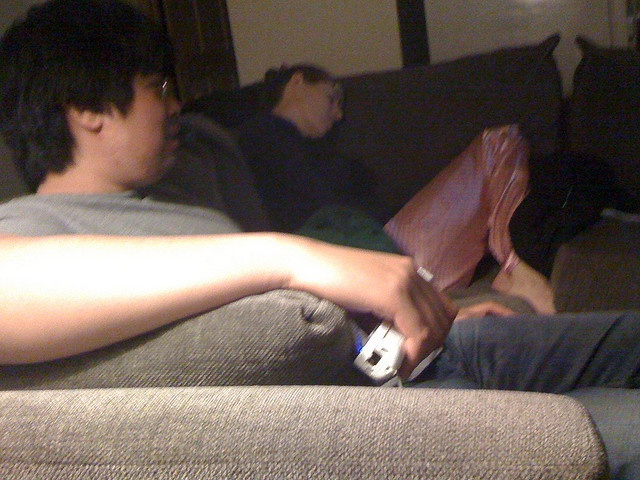Describe the objects in this image and their specific colors. I can see people in black, ivory, gray, and tan tones, couch in black, darkgray, gray, and tan tones, couch in black, gray, and darkgray tones, people in black, brown, and maroon tones, and remote in black, white, darkgray, gray, and tan tones in this image. 